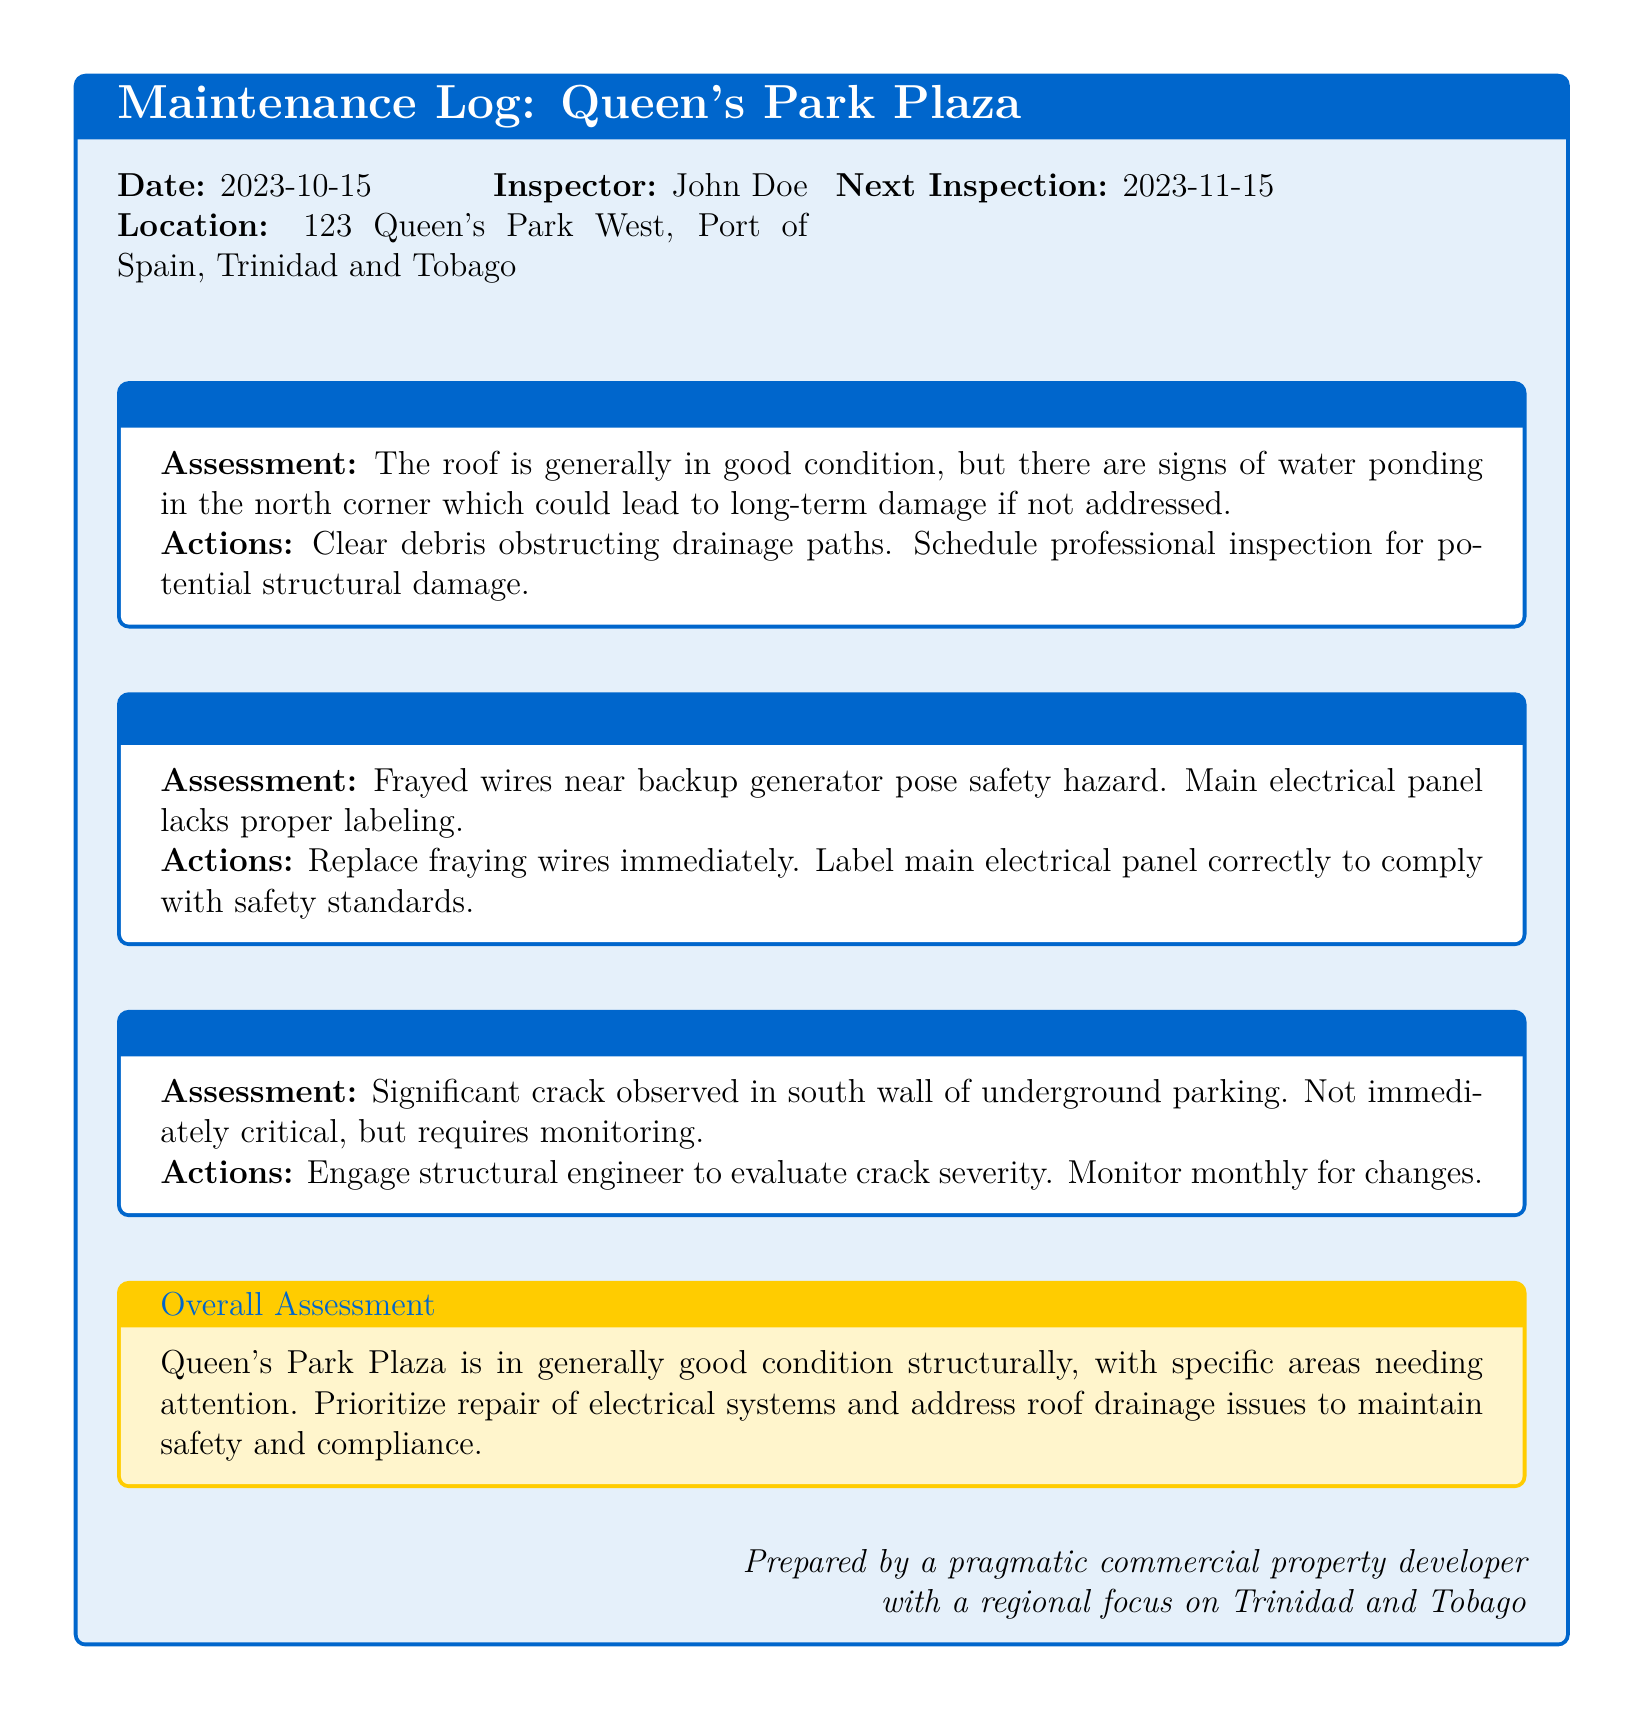what is the date of the inspection? The date of the inspection is mentioned at the beginning of the log.
Answer: 2023-10-15 who is the inspector? The name of the inspector is provided next to the inspection date.
Answer: John Doe what is the location of the inspection? The location is specified in the header of the log.
Answer: 123 Queen's Park West, Port of Spain, Trinidad and Tobago what is the recommended action for the roof? The recommended action for the roof is indicated in the roof section of the log.
Answer: Clear debris obstructing drainage paths what significant issue was found in the foundation? The foundation section mentions a specific issue observed during the inspection.
Answer: Significant crack in south wall what should be done about the frayed wires? The action required for the frayed wires is detailed in the electrical systems section.
Answer: Replace fraying wires immediately when is the next inspection scheduled? The date for the next inspection is noted in the log.
Answer: 2023-11-15 what is the overall structural assessment of Queen's Park Plaza? The overall assessment is summarized at the end of the log.
Answer: Generally good condition structurally why is there a concern regarding the roof? The reason for concern is mentioned in the assessment of the roof section.
Answer: Signs of water ponding who should evaluate the crack in the foundation? The document specifies who should be engaged for further assessment of the foundation issue.
Answer: Structural engineer 